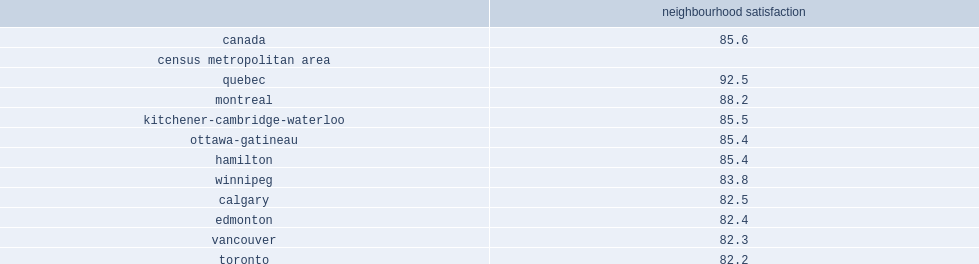Across the 10 largest census metropolitan areas (cmas), what was the proportion of canadians households reporting they are satisfied (satisfied or very satisfied) with their neighbourhood in toronto? 82.2. Across the 10 largest census metropolitan areas (cmas), what was the proportion of canadians households reporting they are satisfied (satisfied or very satisfied) with their neighbourhood in quebec? 92.5. How many percent of residents in quebec had neighbourhood satisfaction rates above the national average? 92.5. How many percent of residents in montreal had neighbourhood satisfaction rates above the national average? 88.2. What is the average rate of national residents neighbourhood satisfaction? 85.6. 